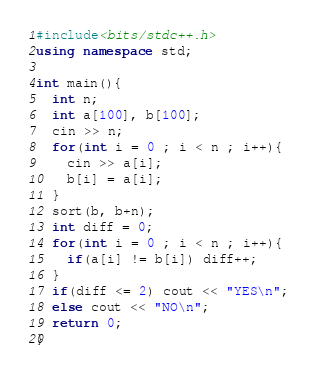Convert code to text. <code><loc_0><loc_0><loc_500><loc_500><_C++_>#include<bits/stdc++.h>
using namespace std;

int main(){
  int n;
  int a[100], b[100];
  cin >> n;
  for(int i = 0 ; i < n ; i++){
    cin >> a[i];
    b[i] = a[i];
  }
  sort(b, b+n);
  int diff = 0;
  for(int i = 0 ; i < n ; i++){
    if(a[i] != b[i]) diff++;
  }
  if(diff <= 2) cout << "YES\n";
  else cout << "NO\n";
  return 0;
}</code> 